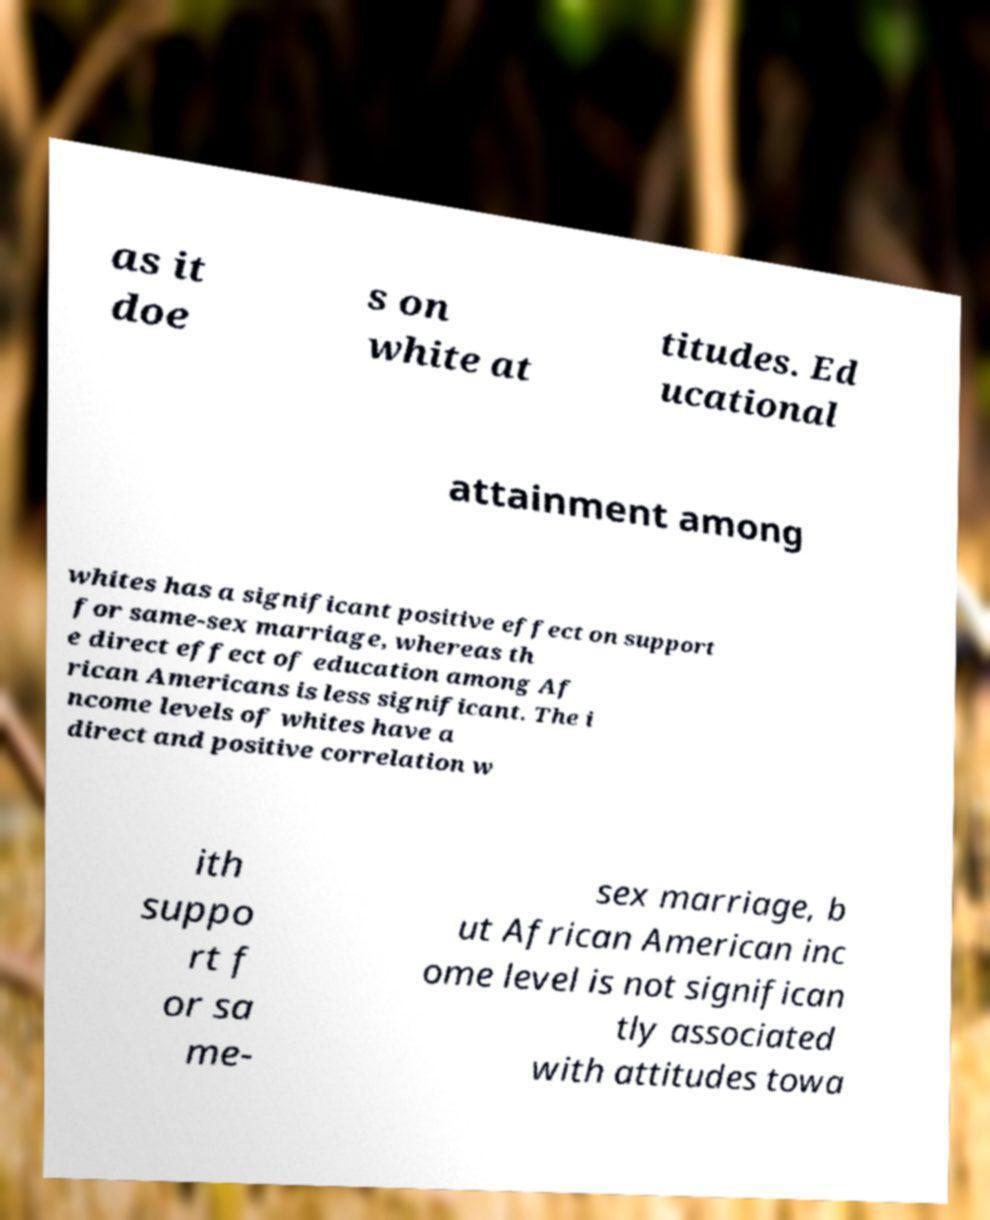What messages or text are displayed in this image? I need them in a readable, typed format. as it doe s on white at titudes. Ed ucational attainment among whites has a significant positive effect on support for same-sex marriage, whereas th e direct effect of education among Af rican Americans is less significant. The i ncome levels of whites have a direct and positive correlation w ith suppo rt f or sa me- sex marriage, b ut African American inc ome level is not significan tly associated with attitudes towa 